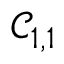Convert formula to latex. <formula><loc_0><loc_0><loc_500><loc_500>\mathcal { C } _ { 1 , 1 }</formula> 